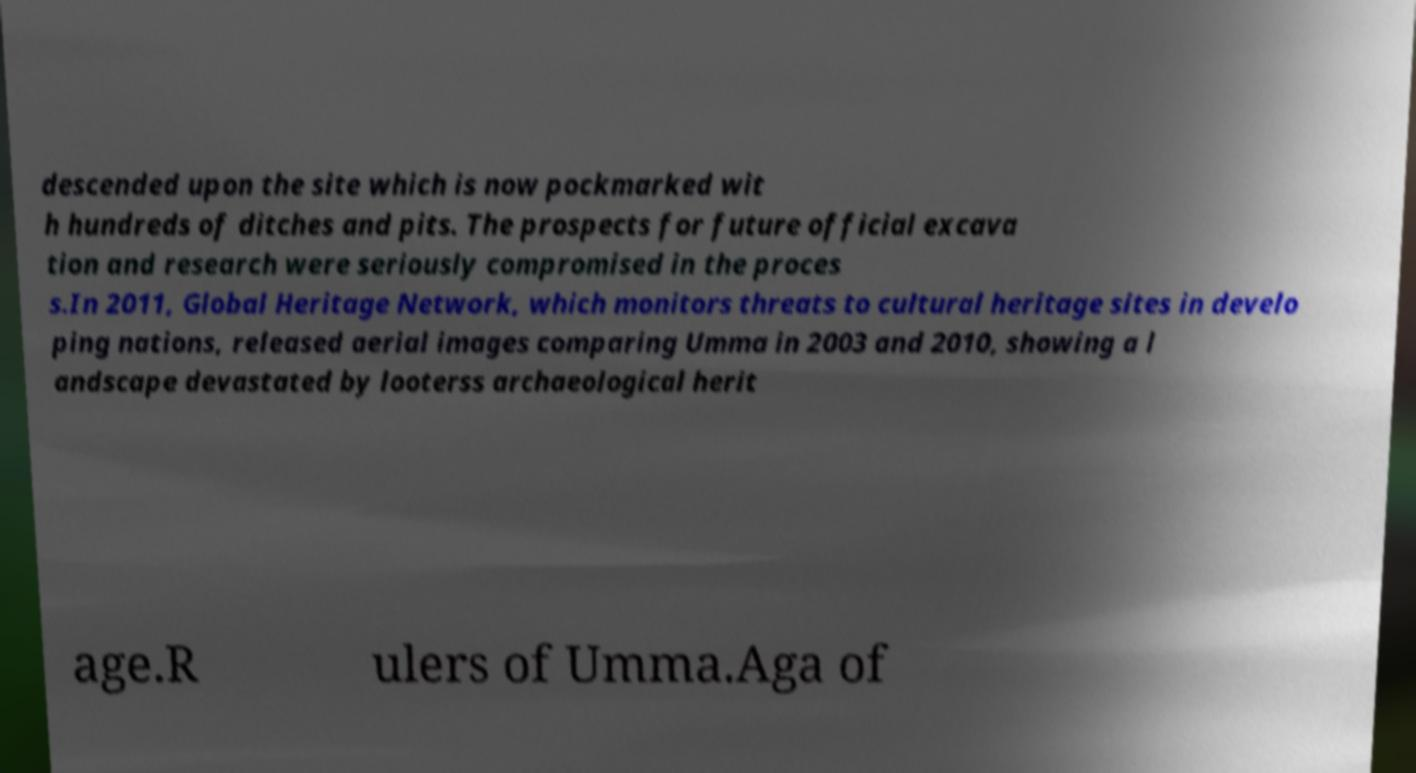There's text embedded in this image that I need extracted. Can you transcribe it verbatim? descended upon the site which is now pockmarked wit h hundreds of ditches and pits. The prospects for future official excava tion and research were seriously compromised in the proces s.In 2011, Global Heritage Network, which monitors threats to cultural heritage sites in develo ping nations, released aerial images comparing Umma in 2003 and 2010, showing a l andscape devastated by looterss archaeological herit age.R ulers of Umma.Aga of 